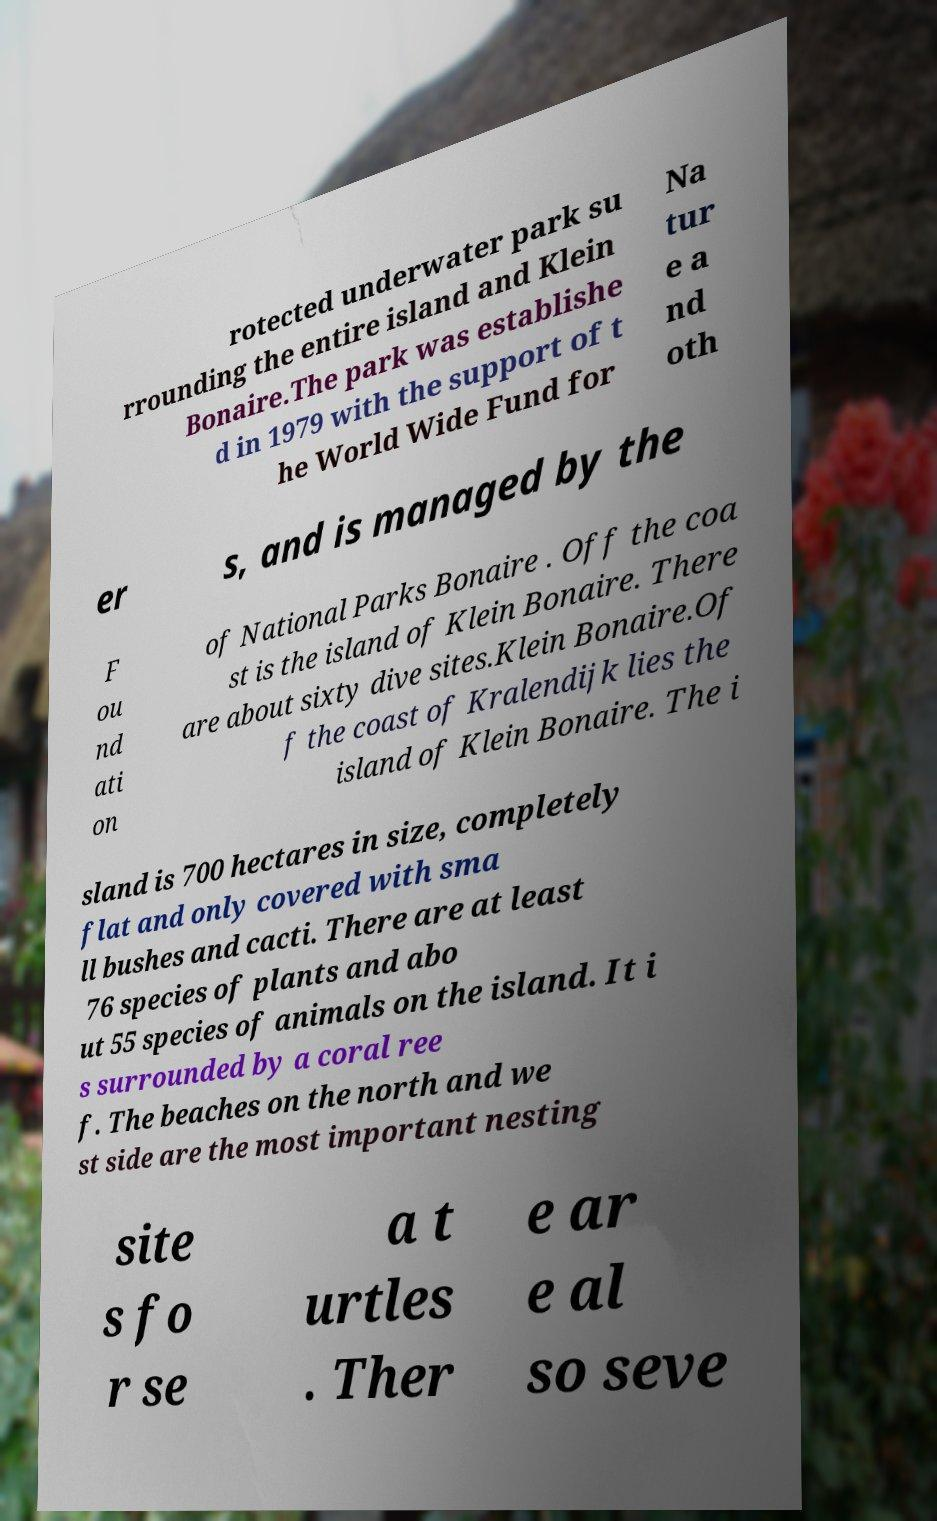Could you assist in decoding the text presented in this image and type it out clearly? rotected underwater park su rrounding the entire island and Klein Bonaire.The park was establishe d in 1979 with the support of t he World Wide Fund for Na tur e a nd oth er s, and is managed by the F ou nd ati on of National Parks Bonaire . Off the coa st is the island of Klein Bonaire. There are about sixty dive sites.Klein Bonaire.Of f the coast of Kralendijk lies the island of Klein Bonaire. The i sland is 700 hectares in size, completely flat and only covered with sma ll bushes and cacti. There are at least 76 species of plants and abo ut 55 species of animals on the island. It i s surrounded by a coral ree f. The beaches on the north and we st side are the most important nesting site s fo r se a t urtles . Ther e ar e al so seve 